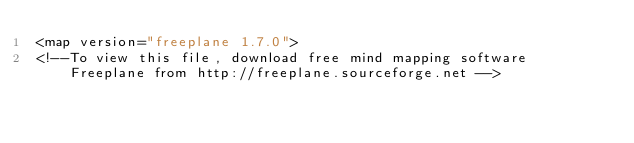<code> <loc_0><loc_0><loc_500><loc_500><_ObjectiveC_><map version="freeplane 1.7.0">
<!--To view this file, download free mind mapping software Freeplane from http://freeplane.sourceforge.net --></code> 